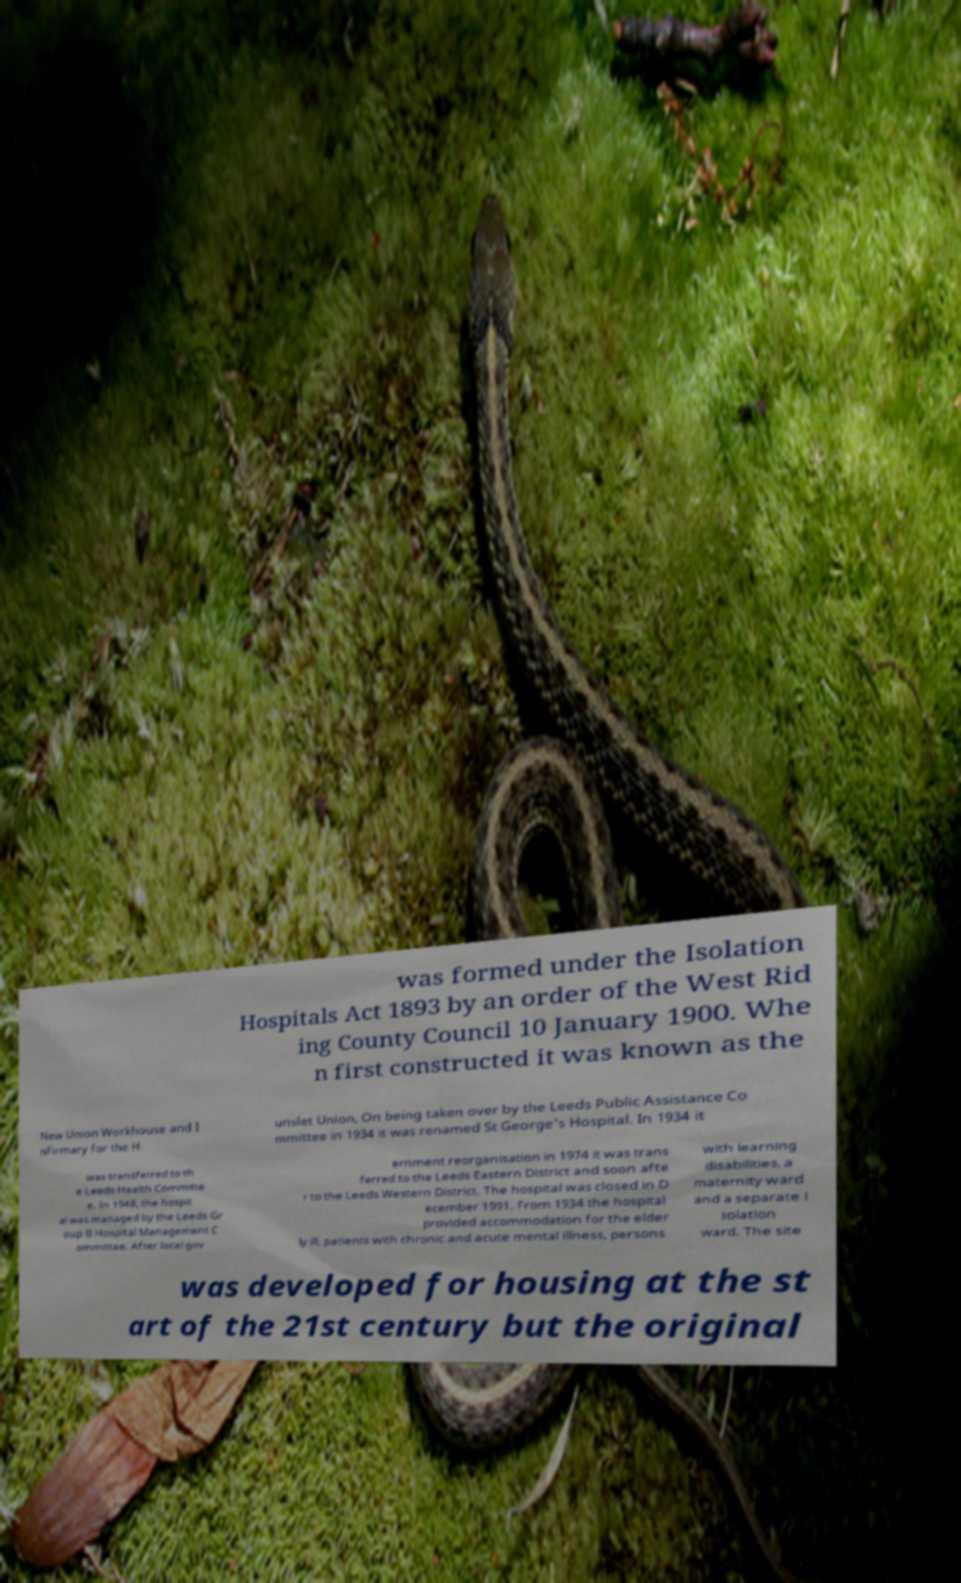Please identify and transcribe the text found in this image. was formed under the Isolation Hospitals Act 1893 by an order of the West Rid ing County Council 10 January 1900. Whe n first constructed it was known as the New Union Workhouse and I nfirmary for the H unslet Union, On being taken over by the Leeds Public Assistance Co mmittee in 1934 it was renamed St George's Hospital. In 1934 it was transferred to th e Leeds Health Committe e. In 1948, the hospit al was managed by the Leeds Gr oup B Hospital Management C ommittee. After local gov ernment reorganisation in 1974 it was trans ferred to the Leeds Eastern District and soon afte r to the Leeds Western District. The hospital was closed in D ecember 1991. From 1934 the hospital provided accommodation for the elder ly ill, patients with chronic and acute mental illness, persons with learning disabilities, a maternity ward and a separate i solation ward. The site was developed for housing at the st art of the 21st century but the original 